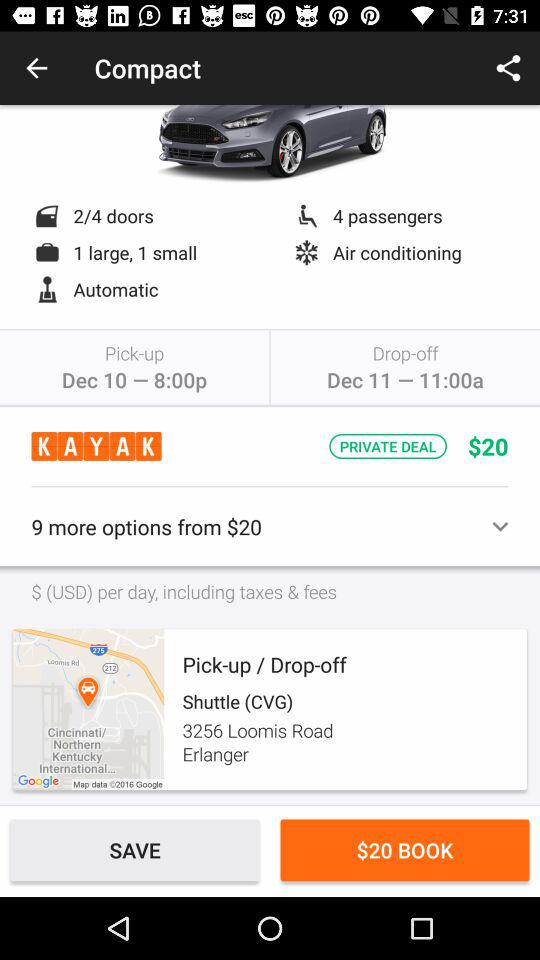How much is the rental per day?
Answer the question using a single word or phrase. $20 